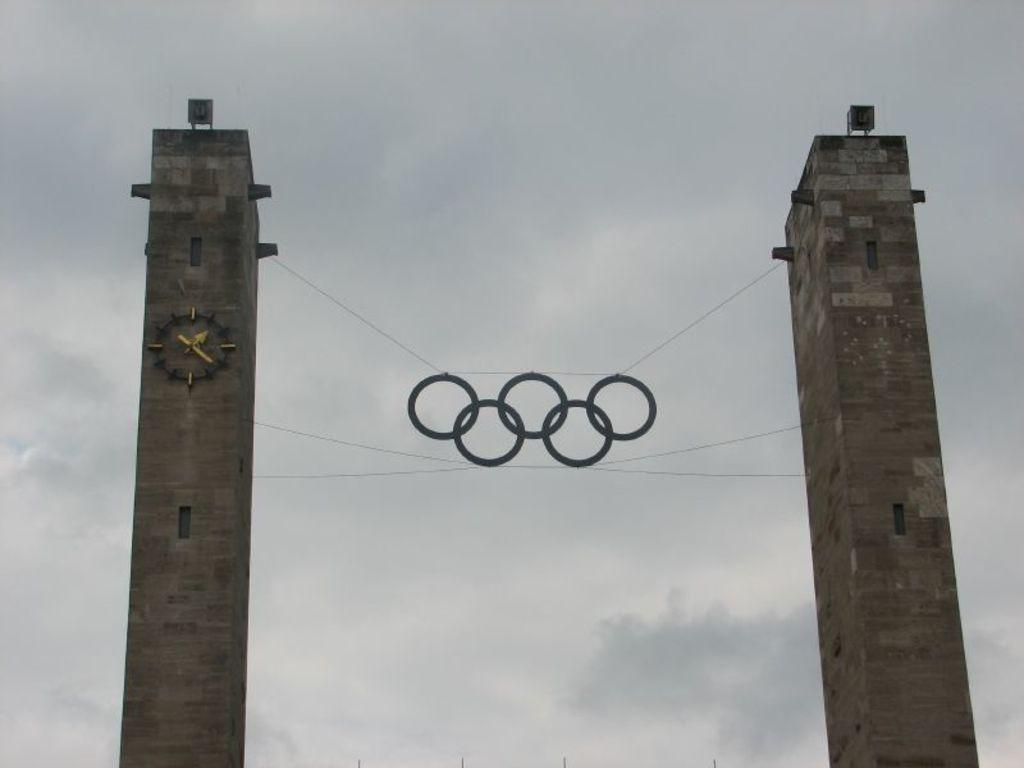What is the main subject of the image? There is a sculpture in the image. How is the sculpture supported? The sculpture is hanged on pillars on both sides. What can be seen in the background of the image? There is sky visible in the background of the image. What is the condition of the sky in the image? Clouds are present in the sky. Can you see a ghost interacting with the sculpture in the image? There is no ghost present in the image, and therefore no such interaction can be observed. 